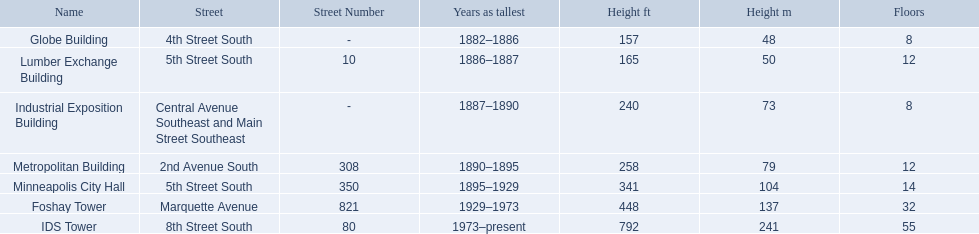How many floors does the lumber exchange building have? 12. What other building has 12 floors? Metropolitan Building. 